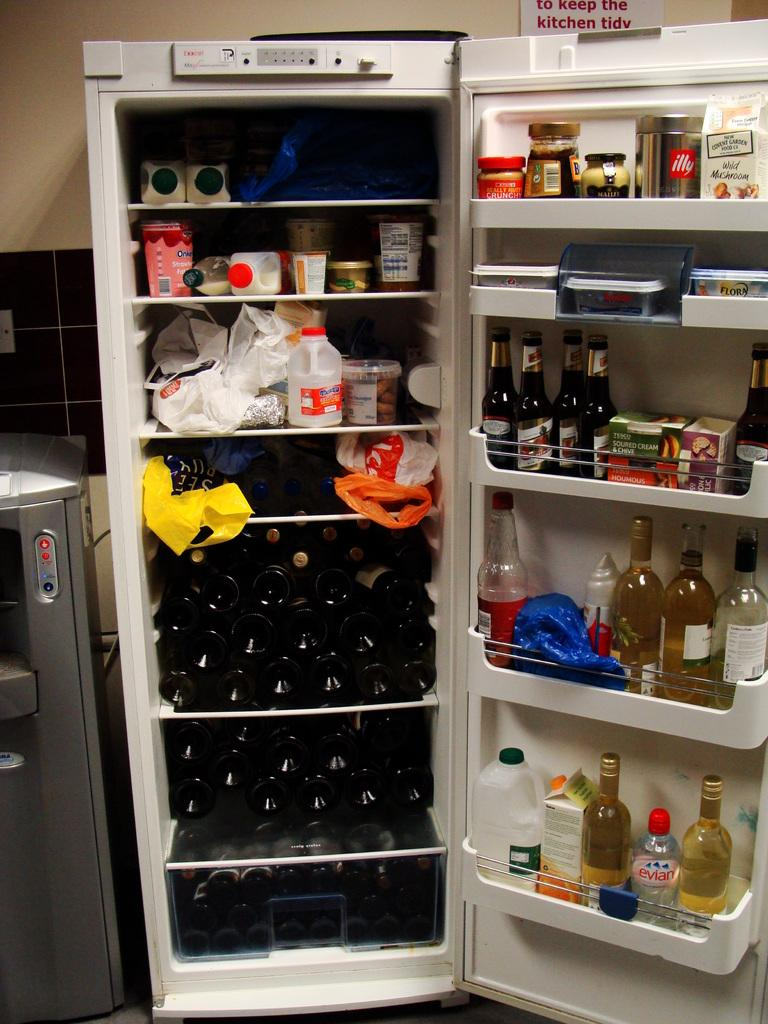What appliance is present in the image? The image contains a fridge. What type of beverage is stored in the fridge? There are wine bottles in the fridge. Are there any other items in the fridge besides wine bottles? Yes, there are other things in the fridge. How is the fridge positioned in the image? The fridge is in an open position. How does the fridge attract the attention of the people in the image? The image does not show any people, so it is not possible to determine how the fridge attracts their attention. 